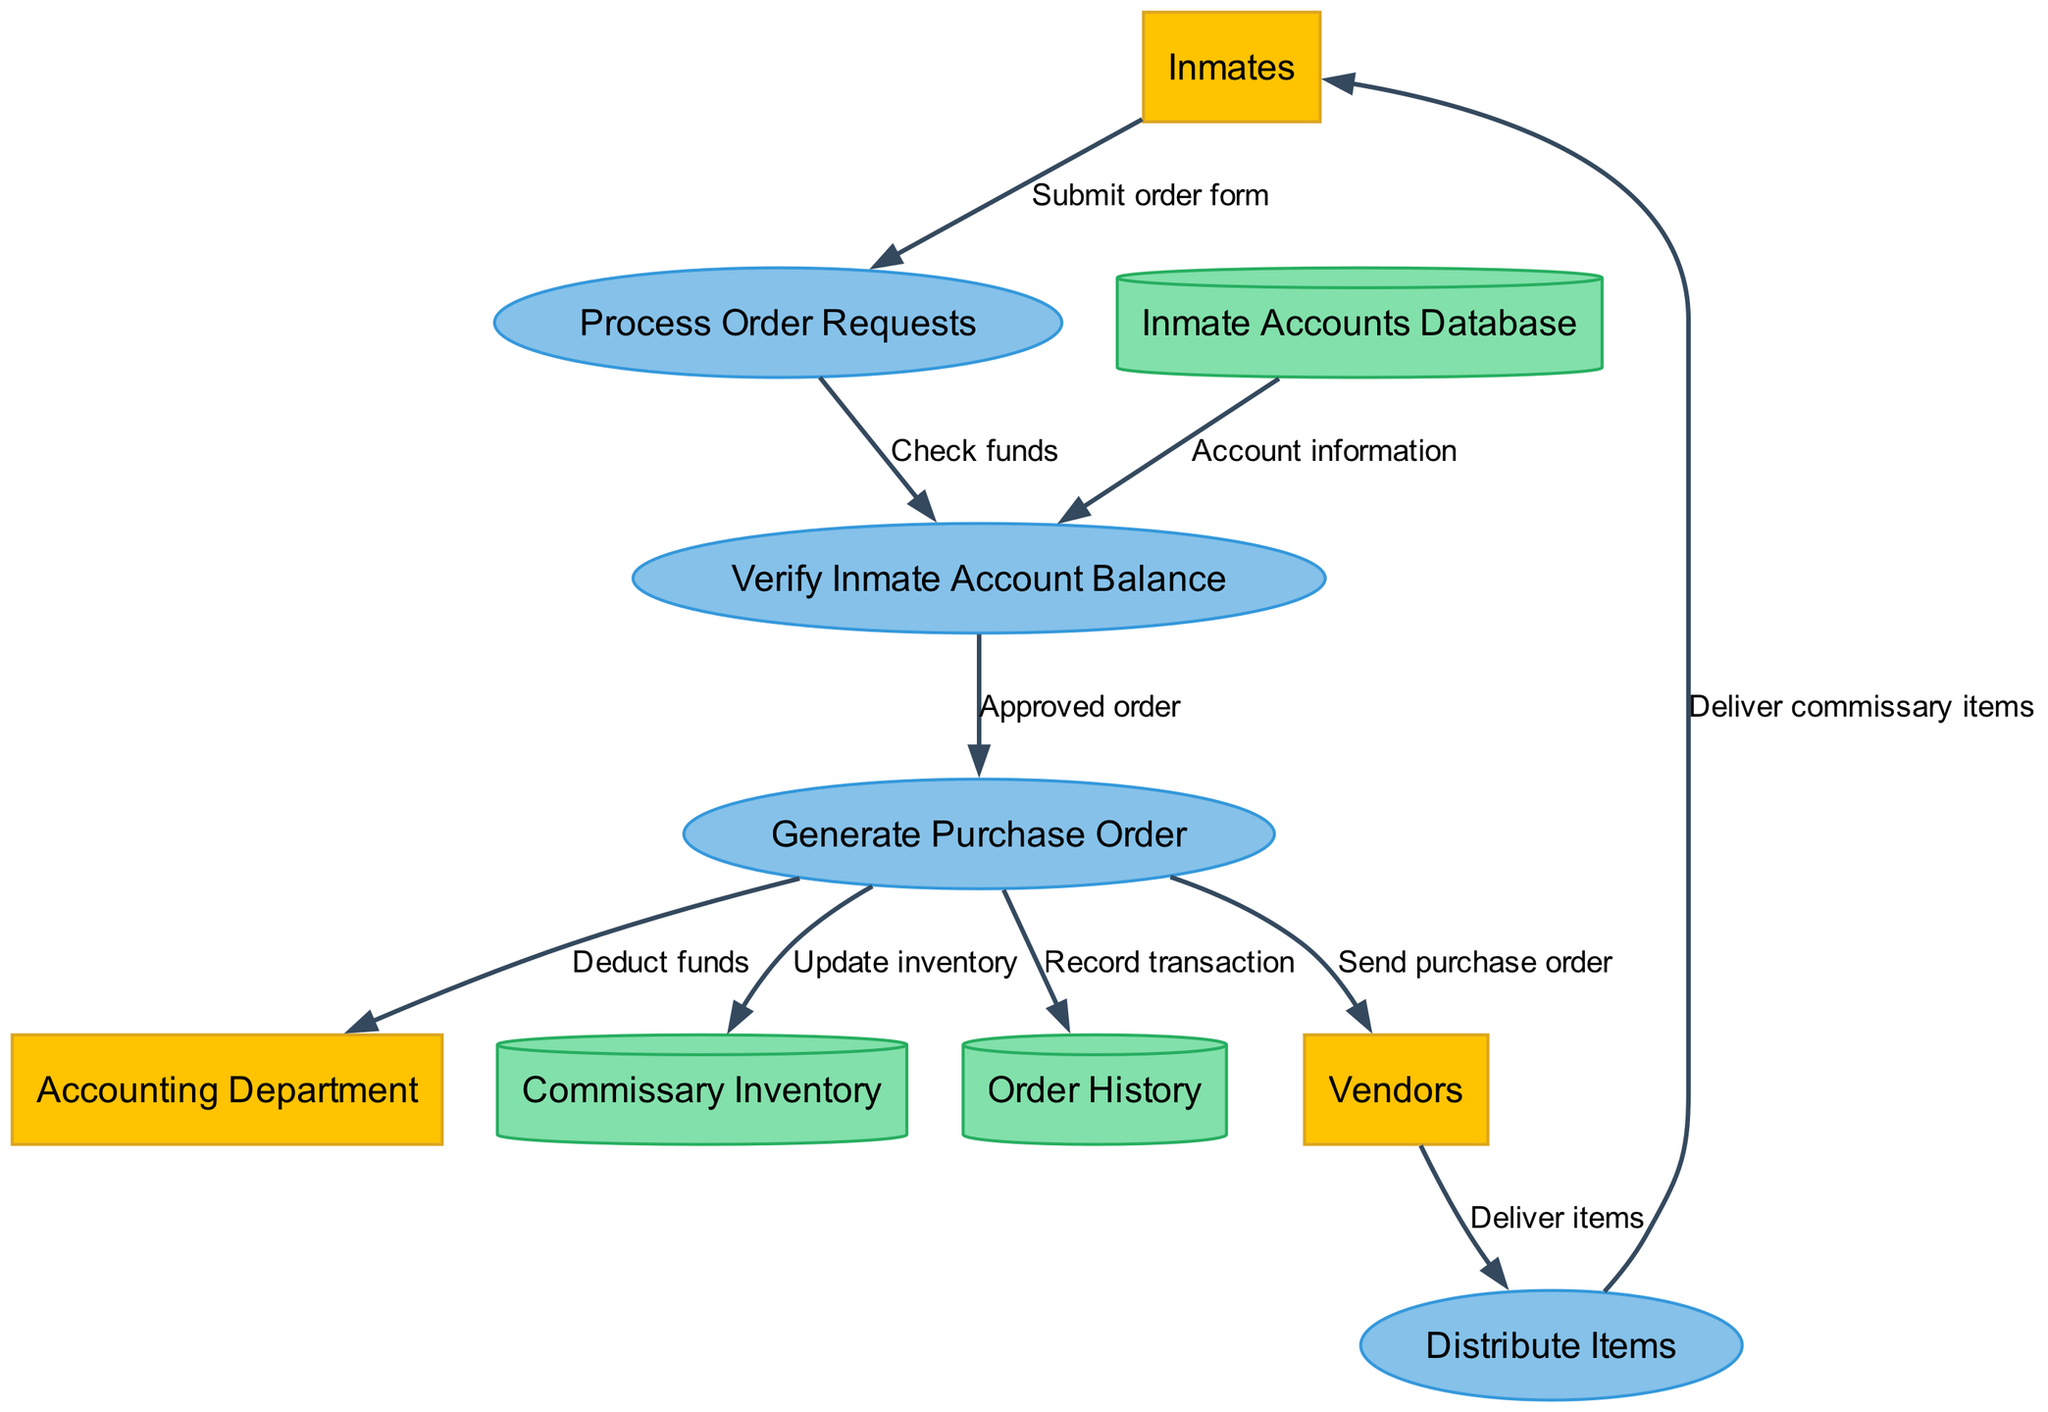What are the external entities in the diagram? The external entities listed in the diagram are specifically identified: "Inmates," "Vendors," and "Accounting Department." They are present in the diagram as separate nodes.
Answer: Inmates, Vendors, Accounting Department How many processes are there in the commissary system? The diagram includes four distinct processes: "Process Order Requests," "Verify Inmate Account Balance," "Generate Purchase Order," and "Distribute Items." Therefore, by counting these, we arrive at the total number of processes.
Answer: 4 What happens after an inmate submits an order form? Upon the submission of the order form by the inmate, the data flow indicates that it is directed to the process "Process Order Requests" to be processed further. This indicates the sequence of events.
Answer: Process Order Requests Which process is responsible for sending a purchase order? The "Generate Purchase Order" process is responsible for sending the purchase order to the vendors, as indicated by the data flow originating from it.
Answer: Generate Purchase Order What is updated when a purchase order is generated? When a purchase order is generated, it updates the "Commissary Inventory," which is defined in the data flow connecting these two nodes, thereby indicating the effect of this process on the inventory.
Answer: Commissary Inventory What data flow occurs between the "Generate Purchase Order" process and the "Accounting Department"? The diagram shows that the flow between the "Generate Purchase Order" and the "Accounting Department" includes the action of deducting funds, highlighting a financial transaction related to the order.
Answer: Deduct funds What type of database stores account information for inmates? The "Inmate Accounts Database" is the designated database in the diagram specifically for storing inmate account information, as indicated by the label connecting it to the relevant processes.
Answer: Inmate Accounts Database Which entity is responsible for delivering items? The "Vendors" external entity is responsible for delivering items to inmates, as indicated by the flow from "Vendors" to "Distribute Items." This signifies their role in the system.
Answer: Vendors How does the system register a transaction? A transaction is recorded in the "Order History" whenever a purchase order is generated, as depicted by the data flow leading from the purchase order process to this data store.
Answer: Order History 